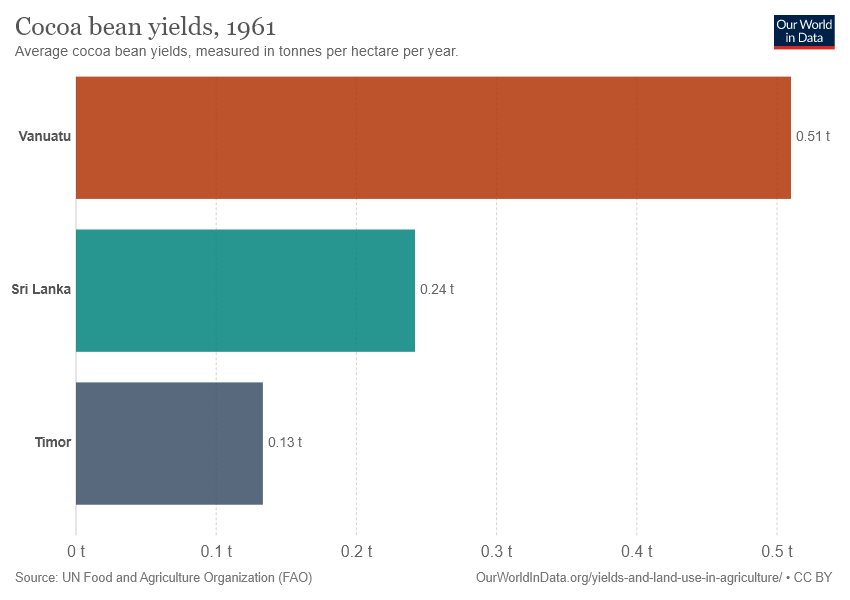Identify some key points in this picture. The second largest value in the chart is 0.24. 